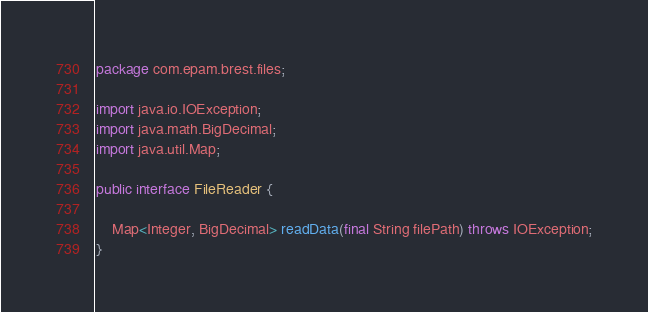Convert code to text. <code><loc_0><loc_0><loc_500><loc_500><_Java_>package com.epam.brest.files;

import java.io.IOException;
import java.math.BigDecimal;
import java.util.Map;

public interface FileReader {

    Map<Integer, BigDecimal> readData(final String filePath) throws IOException;
}
</code> 